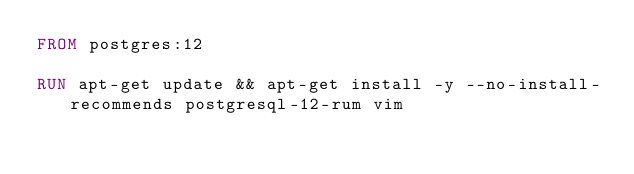Convert code to text. <code><loc_0><loc_0><loc_500><loc_500><_Dockerfile_>FROM postgres:12

RUN apt-get update && apt-get install -y --no-install-recommends postgresql-12-rum vim
</code> 